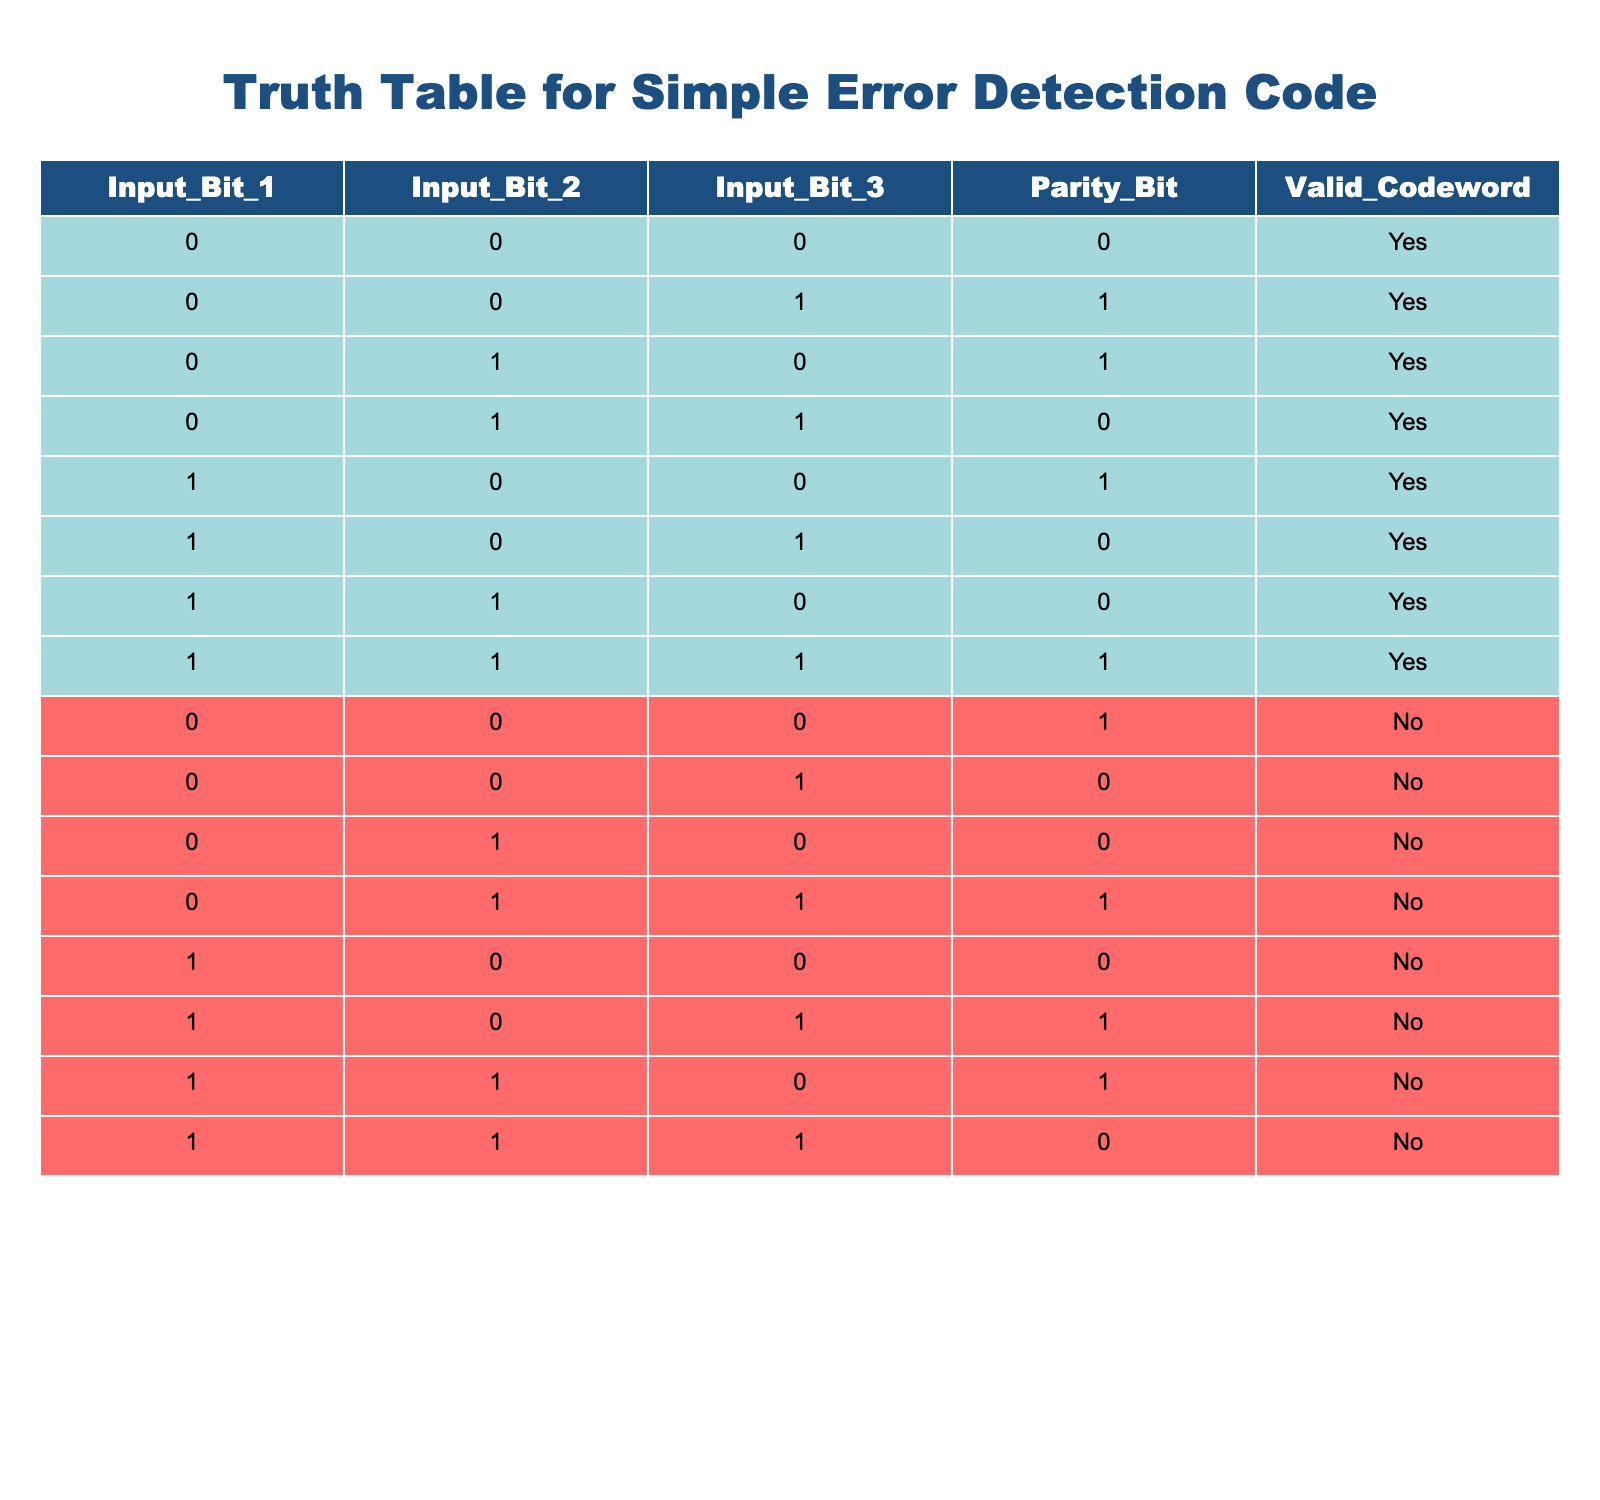What is the valid codeword for the input bits 1, 1, 1? By looking at the row where Input_Bit_1, Input_Bit_2, and Input_Bit_3 all have a value of 1, we see that the corresponding Valid_Codeword column has a value of "Yes".
Answer: Yes How many combinations of input bits result in a valid codeword? Counting the rows where the Valid_Codeword is "Yes", we find there are 8 combinations: (0,0,0), (0,0,1), (0,1,0), (0,1,1), (1,0,0), (1,0,1), (1,1,0), (1,1,1).
Answer: 8 What value does the parity bit take for the input bits 1, 0, 1? The row for Input_Bit_1 = 1, Input_Bit_2 = 0, Input_Bit_3 = 1 shows that the Parity_Bit has a value of 0.
Answer: 0 Is the combination of input bits 0, 0, 0 a valid codeword? Checking the row for Input_Bit_1 = 0, Input_Bit_2 = 0, Input_Bit_3 = 0, the Valid_Codeword shows "Yes", meaning it is a valid codeword.
Answer: Yes If the input bits are 1, 1, 0, what is the output for the parity bit? Looking at the row for Input_Bit_1 = 1, Input_Bit_2 = 1, Input_Bit_3 = 0, we find the Parity_Bit is 0.
Answer: 0 How many combinations have an even parity bit that are also valid codewords? We filter for rows with an even parity bit (0 or 2) and then check the Valid_Codeword. The valid combinations (0,0,0), (0,1,1), (1,0,0), and (1,0,1) are among a total of 5 valid codewords. So the valid combinations with even parity are 5.
Answer: 5 Do input bits 1, 0, 0 with a parity bit 0 result in a valid codeword? For Input_Bit_1 = 1, Input_Bit_2 = 0, Input_Bit_3 = 0, the corresponding Valid_Codeword column has a "No", indicating it is not a valid codeword.
Answer: No What is the parity bit for the input bits 0, 1, 0? From the row for Input_Bit_1 = 0, Input_Bit_2 = 1, and Input_Bit_3 = 0, we look at the Parity_Bit column and find the value is 0.
Answer: 0 